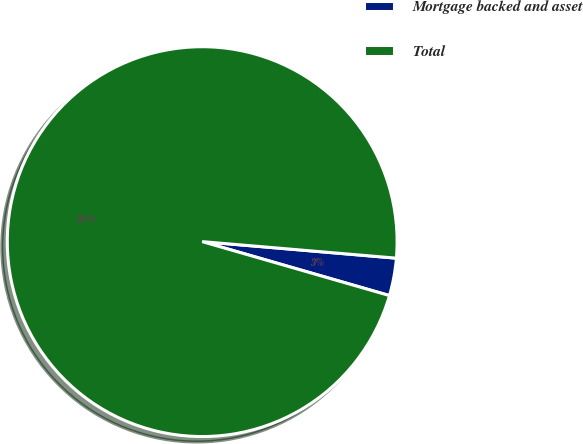<chart> <loc_0><loc_0><loc_500><loc_500><pie_chart><fcel>Mortgage backed and asset<fcel>Total<nl><fcel>3.11%<fcel>96.89%<nl></chart> 